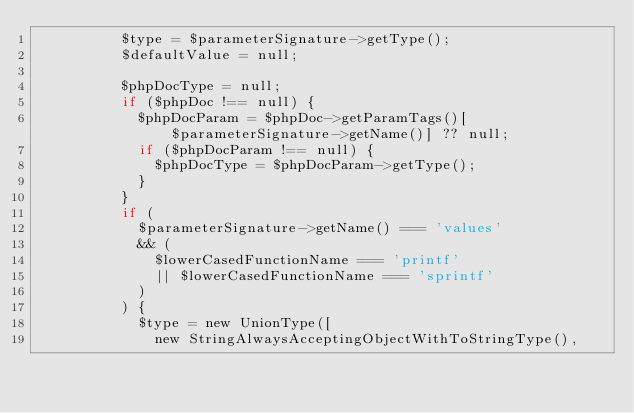Convert code to text. <code><loc_0><loc_0><loc_500><loc_500><_PHP_>					$type = $parameterSignature->getType();
					$defaultValue = null;

					$phpDocType = null;
					if ($phpDoc !== null) {
						$phpDocParam = $phpDoc->getParamTags()[$parameterSignature->getName()] ?? null;
						if ($phpDocParam !== null) {
							$phpDocType = $phpDocParam->getType();
						}
					}
					if (
						$parameterSignature->getName() === 'values'
						&& (
							$lowerCasedFunctionName === 'printf'
							|| $lowerCasedFunctionName === 'sprintf'
						)
					) {
						$type = new UnionType([
							new StringAlwaysAcceptingObjectWithToStringType(),</code> 